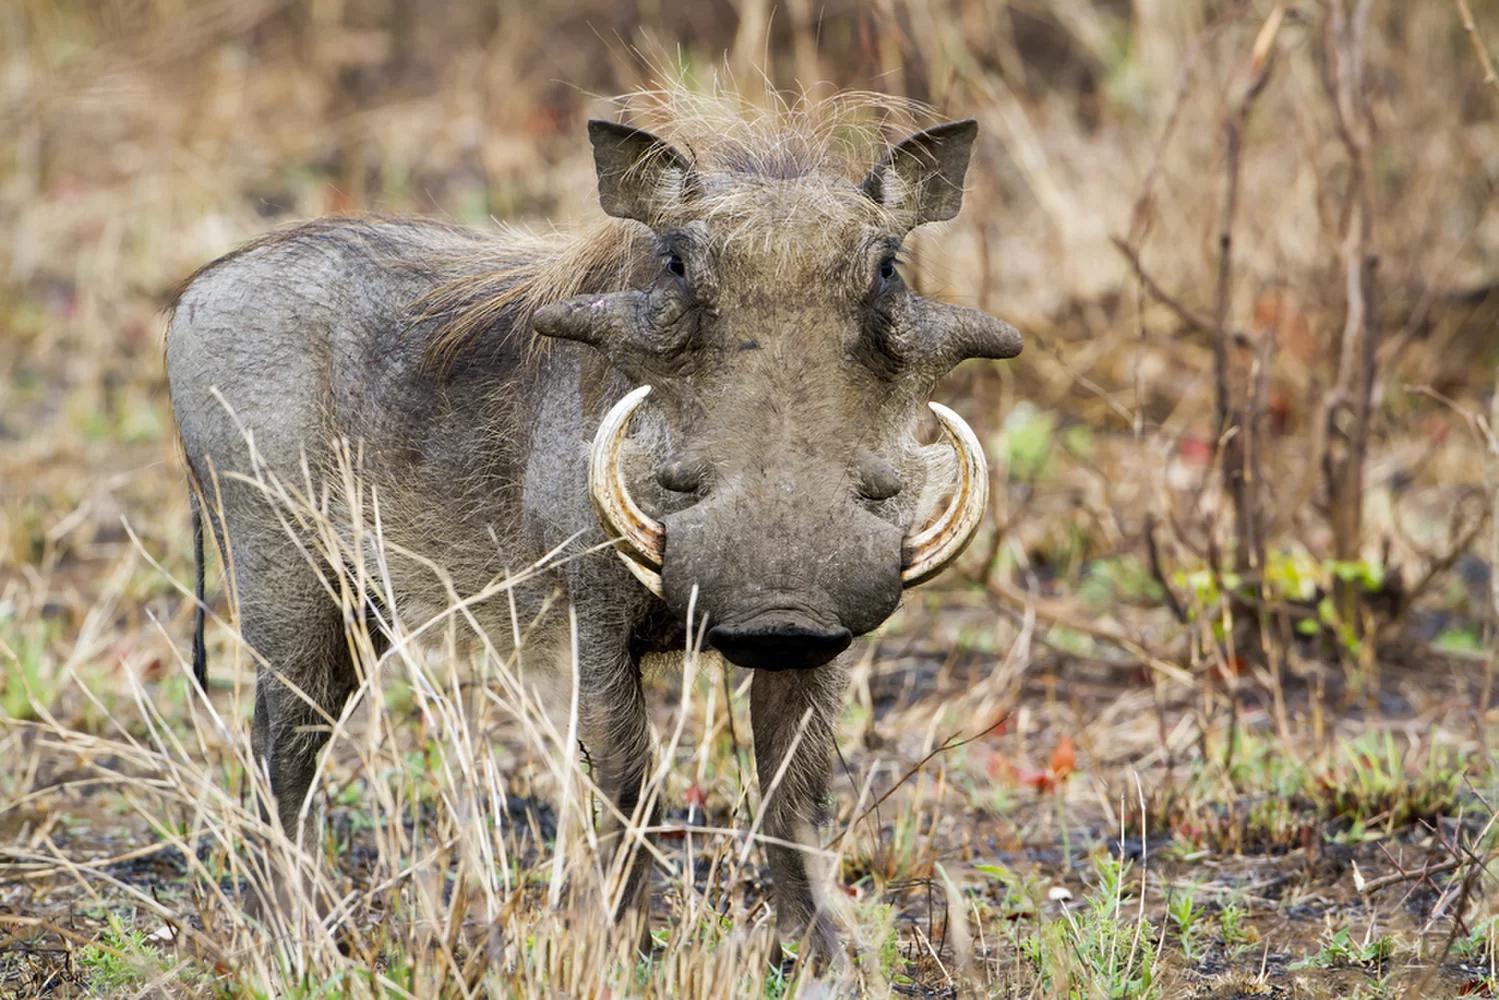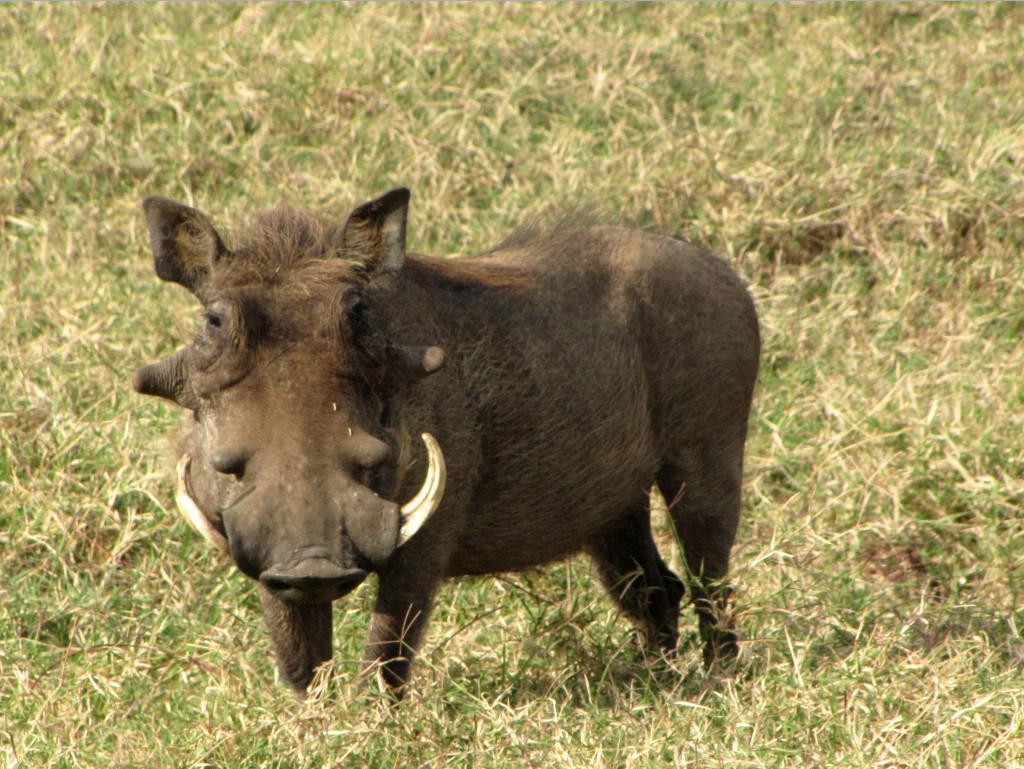The first image is the image on the left, the second image is the image on the right. Assess this claim about the two images: "the hog on the right image is facing left.". Correct or not? Answer yes or no. Yes. 